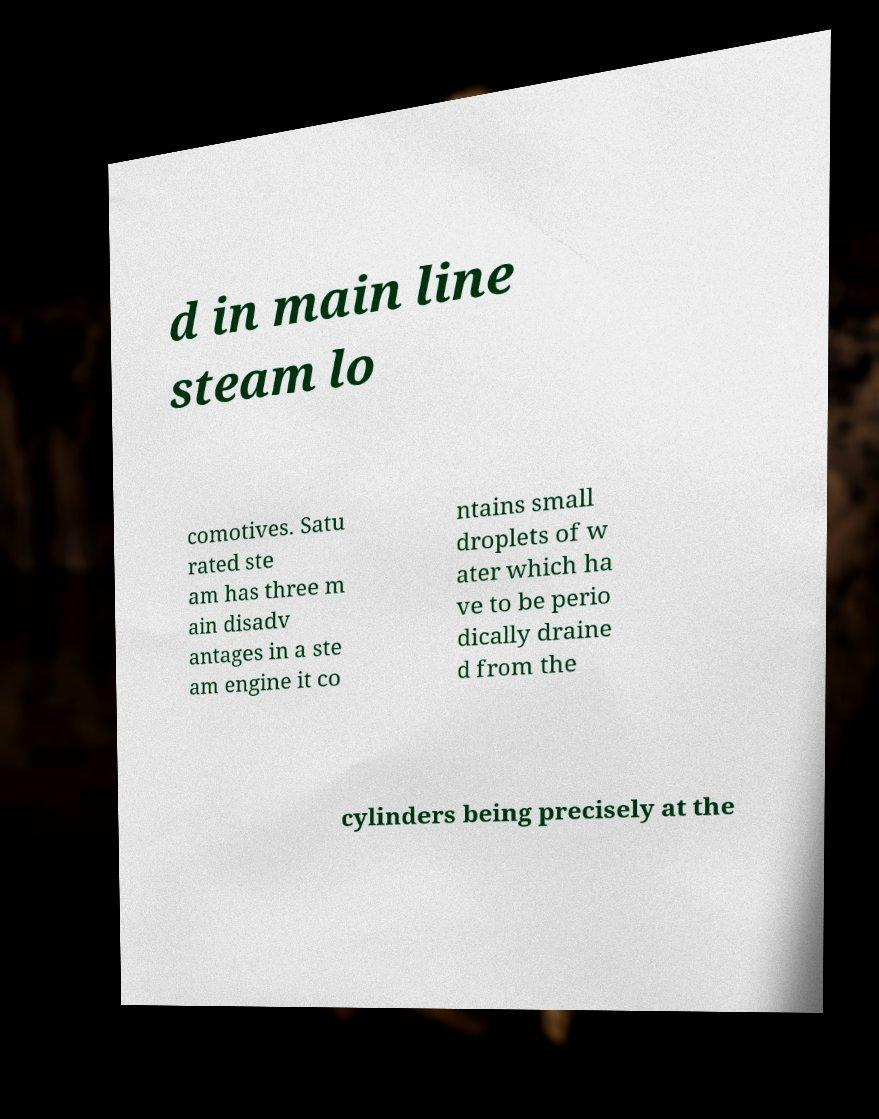I need the written content from this picture converted into text. Can you do that? d in main line steam lo comotives. Satu rated ste am has three m ain disadv antages in a ste am engine it co ntains small droplets of w ater which ha ve to be perio dically draine d from the cylinders being precisely at the 